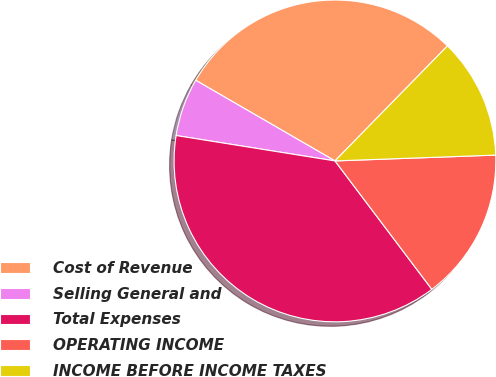Convert chart to OTSL. <chart><loc_0><loc_0><loc_500><loc_500><pie_chart><fcel>Cost of Revenue<fcel>Selling General and<fcel>Total Expenses<fcel>OPERATING INCOME<fcel>INCOME BEFORE INCOME TAXES<nl><fcel>28.97%<fcel>5.83%<fcel>37.81%<fcel>15.29%<fcel>12.1%<nl></chart> 